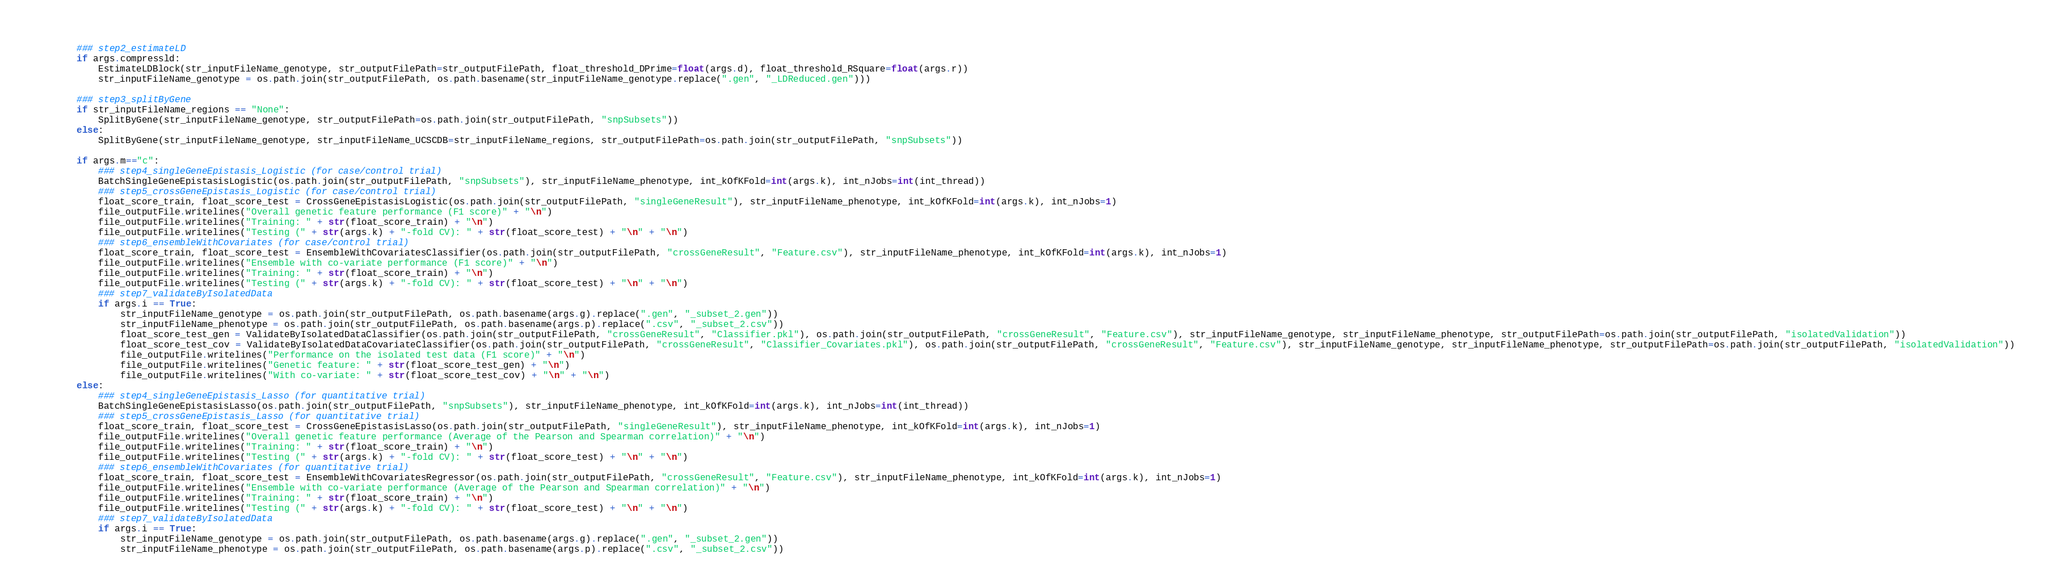Convert code to text. <code><loc_0><loc_0><loc_500><loc_500><_Python_>    
        ### step2_estimateLD
        if args.compressld:
            EstimateLDBlock(str_inputFileName_genotype, str_outputFilePath=str_outputFilePath, float_threshold_DPrime=float(args.d), float_threshold_RSquare=float(args.r))
            str_inputFileName_genotype = os.path.join(str_outputFilePath, os.path.basename(str_inputFileName_genotype.replace(".gen", "_LDReduced.gen")))
        
        ### step3_splitByGene
        if str_inputFileName_regions == "None":
            SplitByGene(str_inputFileName_genotype, str_outputFilePath=os.path.join(str_outputFilePath, "snpSubsets"))
        else:
            SplitByGene(str_inputFileName_genotype, str_inputFileName_UCSCDB=str_inputFileName_regions, str_outputFilePath=os.path.join(str_outputFilePath, "snpSubsets"))
        
        if args.m=="c":
            ### step4_singleGeneEpistasis_Logistic (for case/control trial)
            BatchSingleGeneEpistasisLogistic(os.path.join(str_outputFilePath, "snpSubsets"), str_inputFileName_phenotype, int_kOfKFold=int(args.k), int_nJobs=int(int_thread))
            ### step5_crossGeneEpistasis_Logistic (for case/control trial)
            float_score_train, float_score_test = CrossGeneEpistasisLogistic(os.path.join(str_outputFilePath, "singleGeneResult"), str_inputFileName_phenotype, int_kOfKFold=int(args.k), int_nJobs=1)
            file_outputFile.writelines("Overall genetic feature performance (F1 score)" + "\n")
            file_outputFile.writelines("Training: " + str(float_score_train) + "\n")
            file_outputFile.writelines("Testing (" + str(args.k) + "-fold CV): " + str(float_score_test) + "\n" + "\n")
            ### step6_ensembleWithCovariates (for case/control trial)
            float_score_train, float_score_test = EnsembleWithCovariatesClassifier(os.path.join(str_outputFilePath, "crossGeneResult", "Feature.csv"), str_inputFileName_phenotype, int_kOfKFold=int(args.k), int_nJobs=1)
            file_outputFile.writelines("Ensemble with co-variate performance (F1 score)" + "\n")
            file_outputFile.writelines("Training: " + str(float_score_train) + "\n")
            file_outputFile.writelines("Testing (" + str(args.k) + "-fold CV): " + str(float_score_test) + "\n" + "\n")
            ### step7_validateByIsolatedData
            if args.i == True:
                str_inputFileName_genotype = os.path.join(str_outputFilePath, os.path.basename(args.g).replace(".gen", "_subset_2.gen"))
                str_inputFileName_phenotype = os.path.join(str_outputFilePath, os.path.basename(args.p).replace(".csv", "_subset_2.csv"))
                float_score_test_gen = ValidateByIsolatedDataClassifier(os.path.join(str_outputFilePath, "crossGeneResult", "Classifier.pkl"), os.path.join(str_outputFilePath, "crossGeneResult", "Feature.csv"), str_inputFileName_genotype, str_inputFileName_phenotype, str_outputFilePath=os.path.join(str_outputFilePath, "isolatedValidation"))
                float_score_test_cov = ValidateByIsolatedDataCovariateClassifier(os.path.join(str_outputFilePath, "crossGeneResult", "Classifier_Covariates.pkl"), os.path.join(str_outputFilePath, "crossGeneResult", "Feature.csv"), str_inputFileName_genotype, str_inputFileName_phenotype, str_outputFilePath=os.path.join(str_outputFilePath, "isolatedValidation"))
                file_outputFile.writelines("Performance on the isolated test data (F1 score)" + "\n")
                file_outputFile.writelines("Genetic feature: " + str(float_score_test_gen) + "\n")
                file_outputFile.writelines("With co-variate: " + str(float_score_test_cov) + "\n" + "\n")
        else:
            ### step4_singleGeneEpistasis_Lasso (for quantitative trial)
            BatchSingleGeneEpistasisLasso(os.path.join(str_outputFilePath, "snpSubsets"), str_inputFileName_phenotype, int_kOfKFold=int(args.k), int_nJobs=int(int_thread))
            ### step5_crossGeneEpistasis_Lasso (for quantitative trial)
            float_score_train, float_score_test = CrossGeneEpistasisLasso(os.path.join(str_outputFilePath, "singleGeneResult"), str_inputFileName_phenotype, int_kOfKFold=int(args.k), int_nJobs=1)
            file_outputFile.writelines("Overall genetic feature performance (Average of the Pearson and Spearman correlation)" + "\n")
            file_outputFile.writelines("Training: " + str(float_score_train) + "\n")
            file_outputFile.writelines("Testing (" + str(args.k) + "-fold CV): " + str(float_score_test) + "\n" + "\n")
            ### step6_ensembleWithCovariates (for quantitative trial)
            float_score_train, float_score_test = EnsembleWithCovariatesRegressor(os.path.join(str_outputFilePath, "crossGeneResult", "Feature.csv"), str_inputFileName_phenotype, int_kOfKFold=int(args.k), int_nJobs=1)
            file_outputFile.writelines("Ensemble with co-variate performance (Average of the Pearson and Spearman correlation)" + "\n")
            file_outputFile.writelines("Training: " + str(float_score_train) + "\n")
            file_outputFile.writelines("Testing (" + str(args.k) + "-fold CV): " + str(float_score_test) + "\n" + "\n")
            ### step7_validateByIsolatedData
            if args.i == True:
                str_inputFileName_genotype = os.path.join(str_outputFilePath, os.path.basename(args.g).replace(".gen", "_subset_2.gen"))
                str_inputFileName_phenotype = os.path.join(str_outputFilePath, os.path.basename(args.p).replace(".csv", "_subset_2.csv"))</code> 